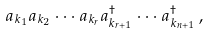<formula> <loc_0><loc_0><loc_500><loc_500>a _ { k _ { 1 } } a _ { k _ { 2 } } \cdot \cdot \cdot a _ { k _ { r } } a _ { k _ { r + 1 } } ^ { \dag } \cdot \cdot \cdot a _ { k _ { n + 1 } } ^ { \dag } \, ,</formula> 